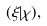Convert formula to latex. <formula><loc_0><loc_0><loc_500><loc_500>( \xi | \chi ) ,</formula> 